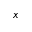Convert formula to latex. <formula><loc_0><loc_0><loc_500><loc_500>x</formula> 